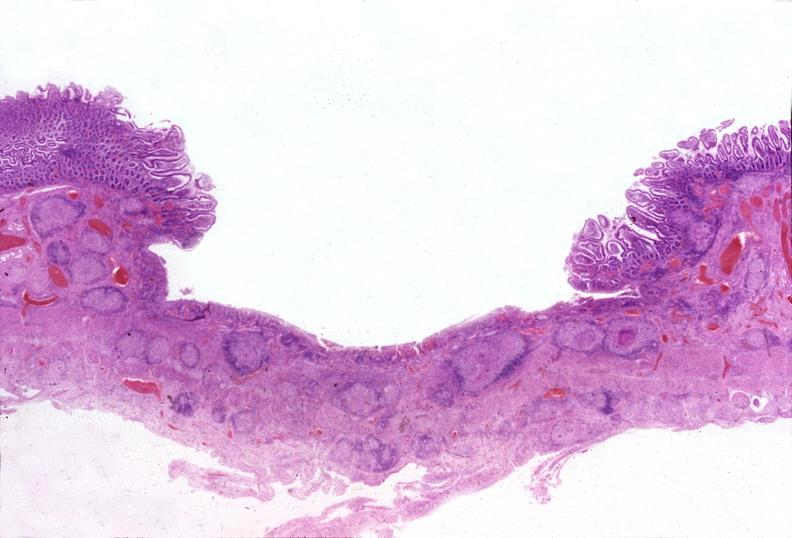what is present?
Answer the question using a single word or phrase. Gastrointestinal 